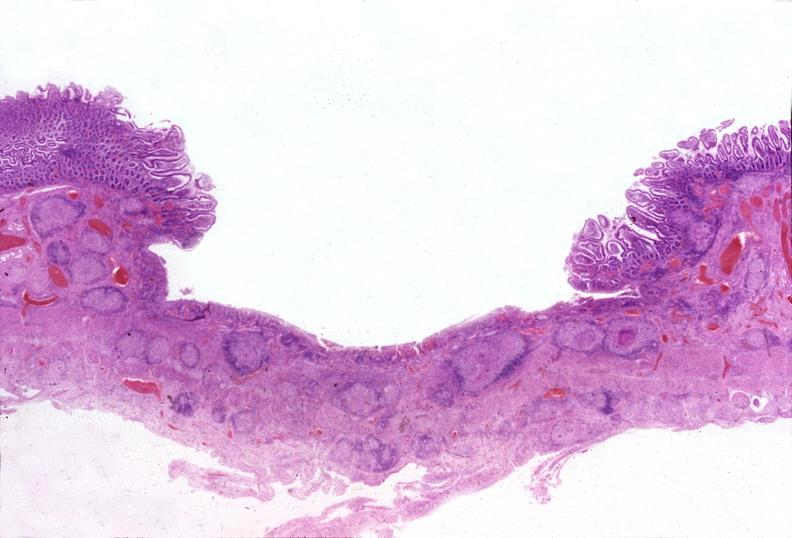what is present?
Answer the question using a single word or phrase. Gastrointestinal 